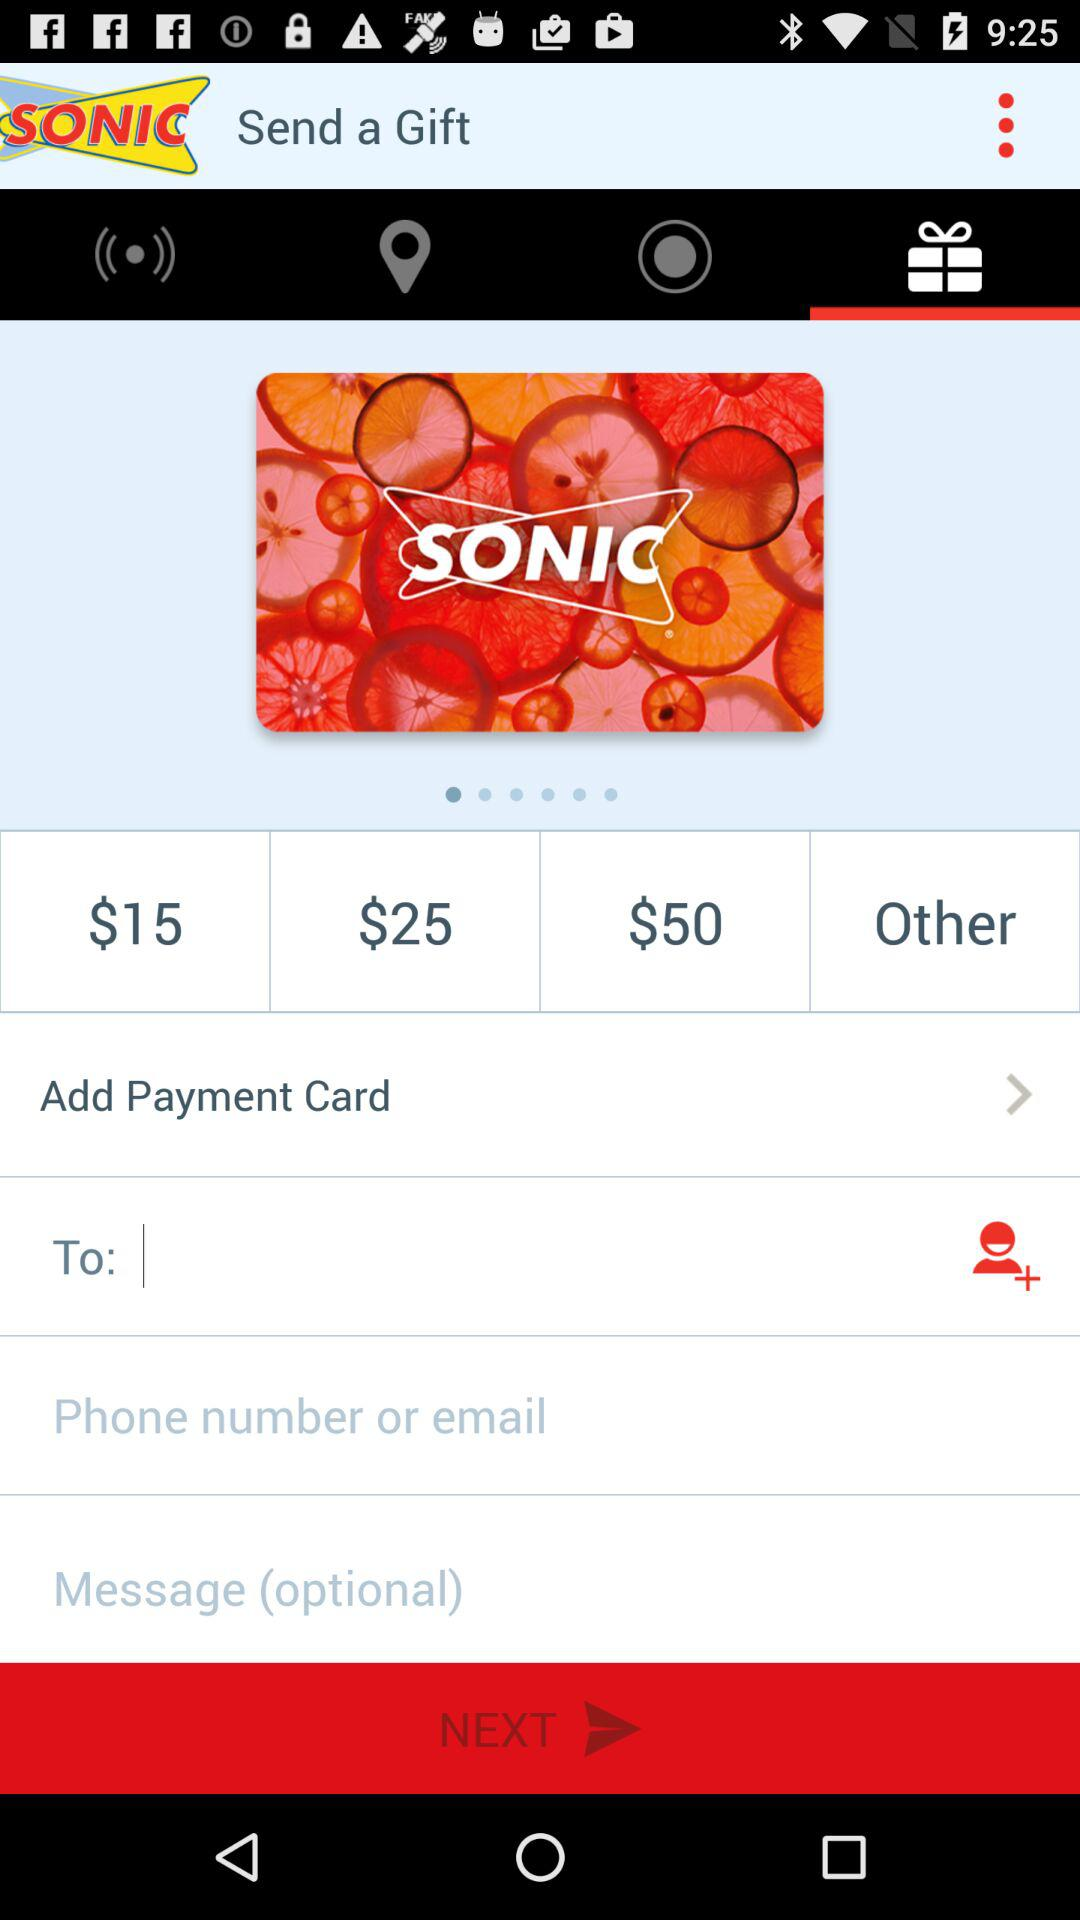What is the cost of the cheapest gift? The cost is $15. 